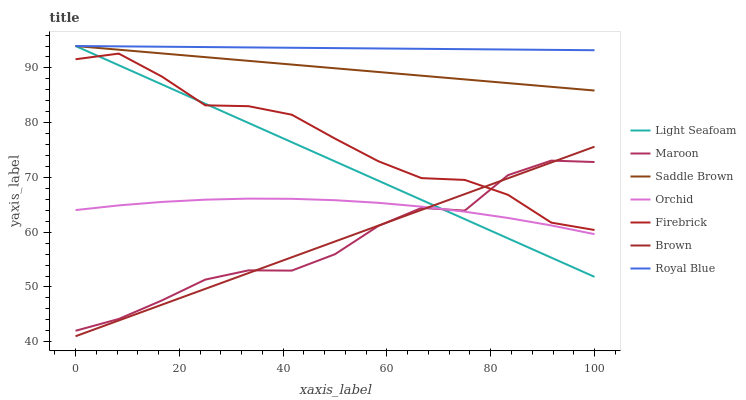Does Maroon have the minimum area under the curve?
Answer yes or no. Yes. Does Royal Blue have the maximum area under the curve?
Answer yes or no. Yes. Does Firebrick have the minimum area under the curve?
Answer yes or no. No. Does Firebrick have the maximum area under the curve?
Answer yes or no. No. Is Saddle Brown the smoothest?
Answer yes or no. Yes. Is Maroon the roughest?
Answer yes or no. Yes. Is Firebrick the smoothest?
Answer yes or no. No. Is Firebrick the roughest?
Answer yes or no. No. Does Brown have the lowest value?
Answer yes or no. Yes. Does Firebrick have the lowest value?
Answer yes or no. No. Does Saddle Brown have the highest value?
Answer yes or no. Yes. Does Firebrick have the highest value?
Answer yes or no. No. Is Firebrick less than Saddle Brown?
Answer yes or no. Yes. Is Saddle Brown greater than Maroon?
Answer yes or no. Yes. Does Brown intersect Maroon?
Answer yes or no. Yes. Is Brown less than Maroon?
Answer yes or no. No. Is Brown greater than Maroon?
Answer yes or no. No. Does Firebrick intersect Saddle Brown?
Answer yes or no. No. 